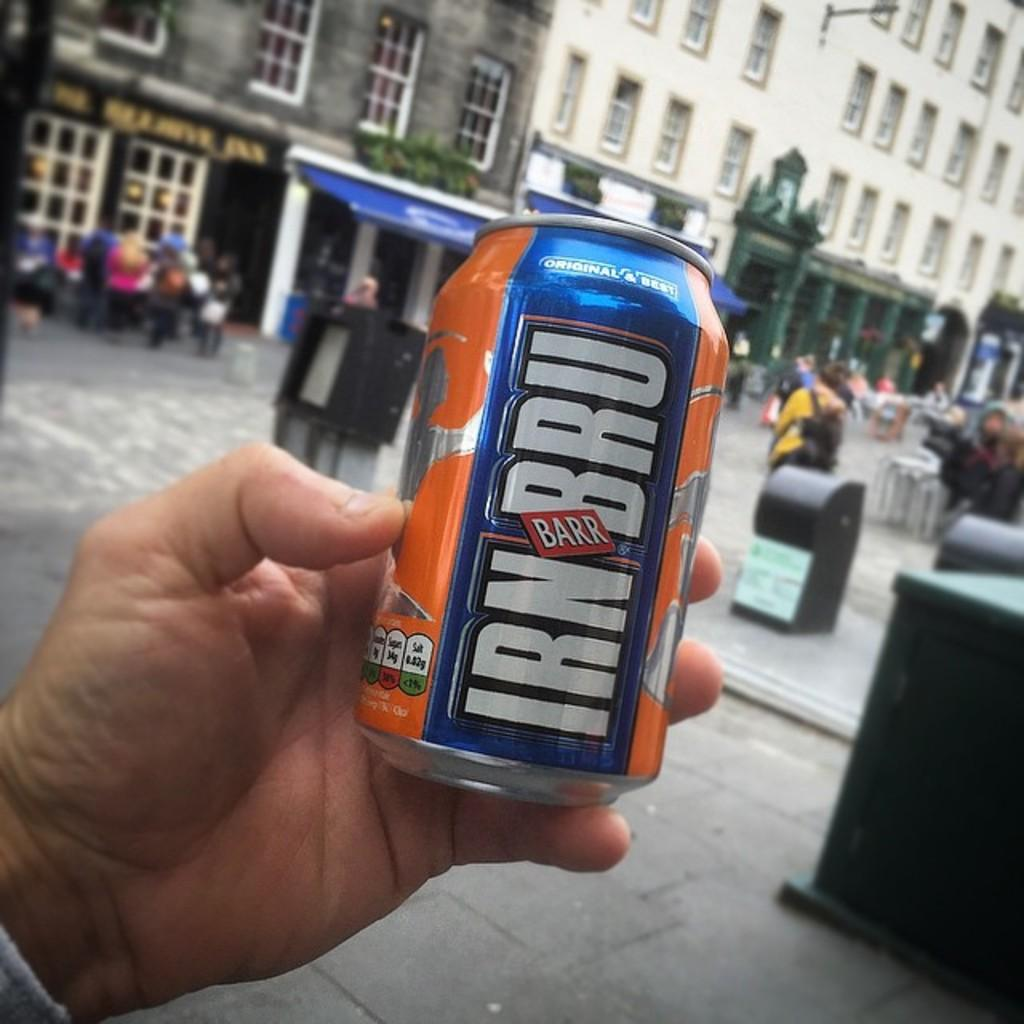<image>
Offer a succinct explanation of the picture presented. A man is holding up a can of IRN BRU in front of a crowded street. 